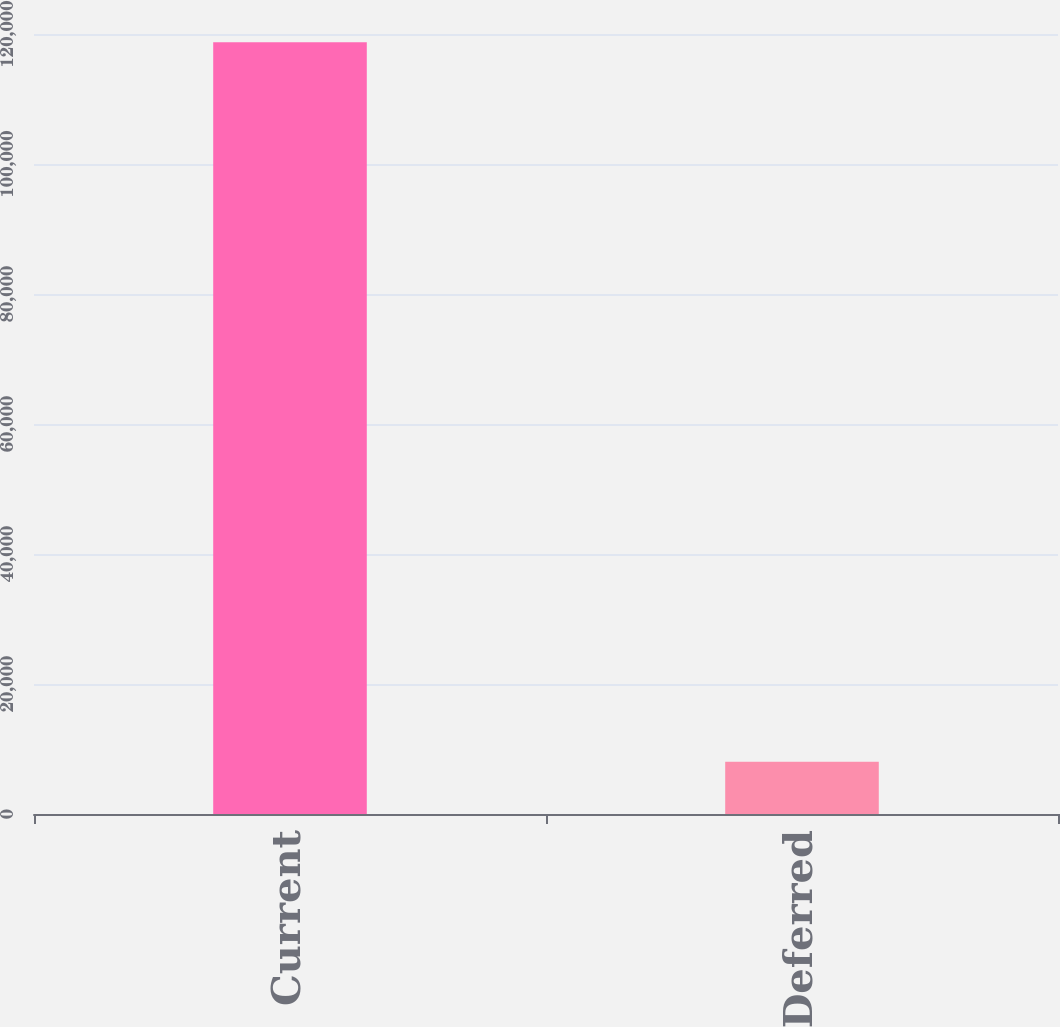Convert chart. <chart><loc_0><loc_0><loc_500><loc_500><bar_chart><fcel>Current<fcel>Deferred<nl><fcel>118741<fcel>8023<nl></chart> 